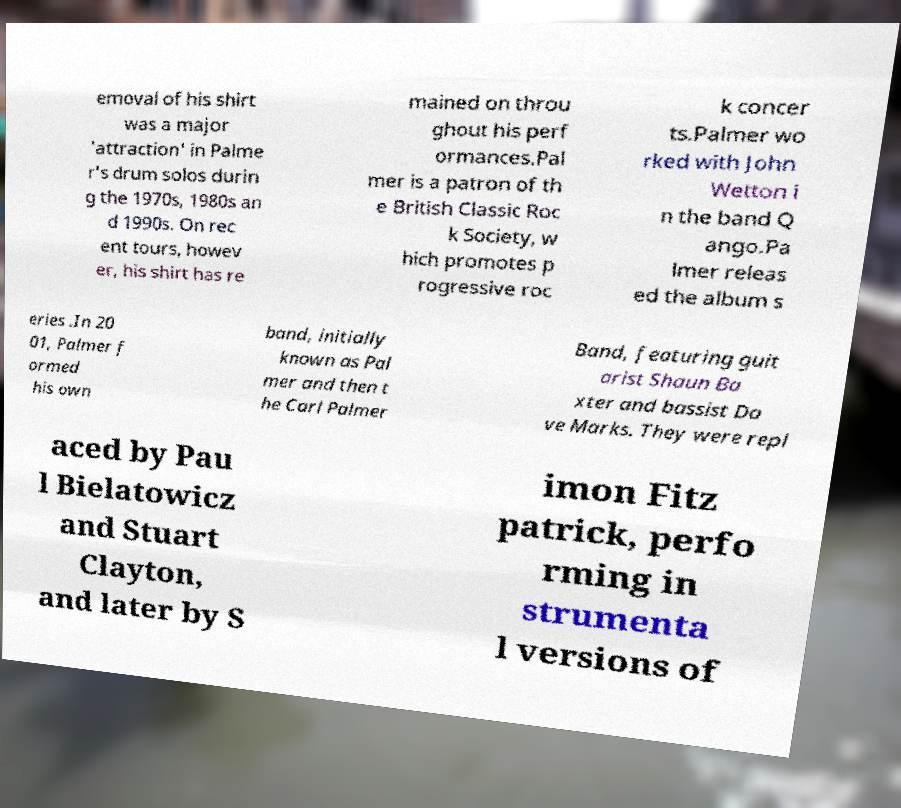Please read and relay the text visible in this image. What does it say? emoval of his shirt was a major 'attraction' in Palme r's drum solos durin g the 1970s, 1980s an d 1990s. On rec ent tours, howev er, his shirt has re mained on throu ghout his perf ormances.Pal mer is a patron of th e British Classic Roc k Society, w hich promotes p rogressive roc k concer ts.Palmer wo rked with John Wetton i n the band Q ango.Pa lmer releas ed the album s eries .In 20 01, Palmer f ormed his own band, initially known as Pal mer and then t he Carl Palmer Band, featuring guit arist Shaun Ba xter and bassist Da ve Marks. They were repl aced by Pau l Bielatowicz and Stuart Clayton, and later by S imon Fitz patrick, perfo rming in strumenta l versions of 